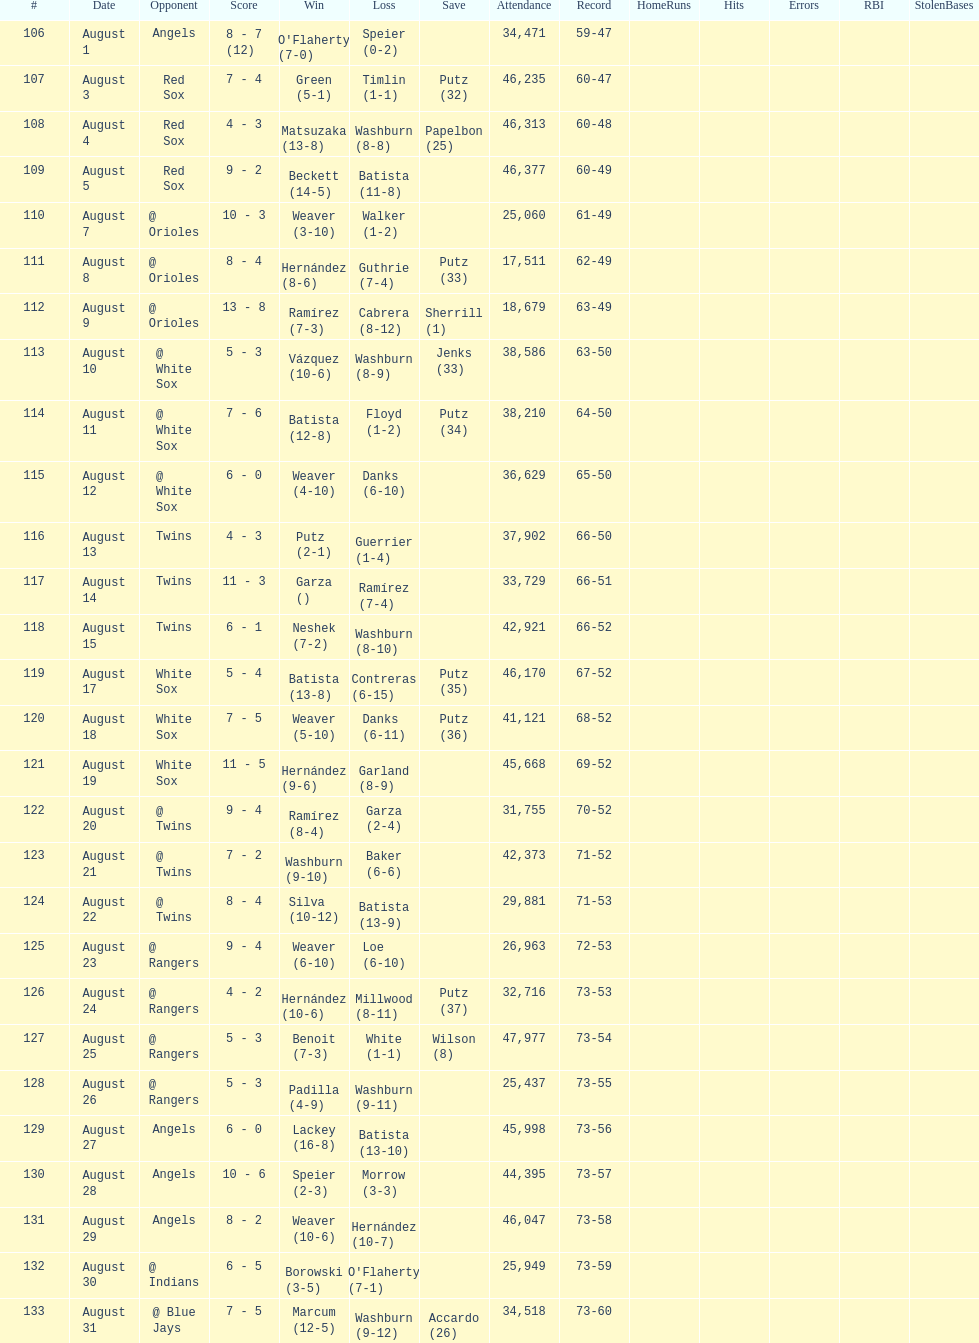Games above 30,000 in attendance 21. 